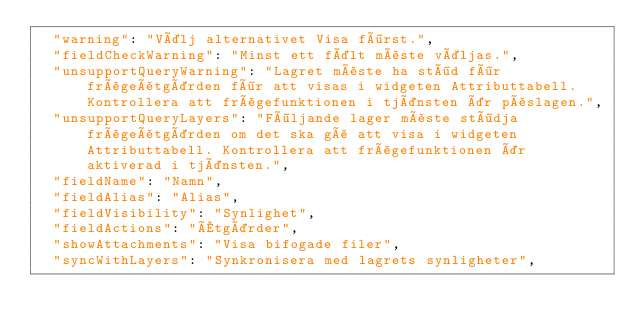Convert code to text. <code><loc_0><loc_0><loc_500><loc_500><_JavaScript_>  "warning": "Välj alternativet Visa först.",
  "fieldCheckWarning": "Minst ett fält måste väljas.",
  "unsupportQueryWarning": "Lagret måste ha stöd för frågeåtgärden för att visas i widgeten Attributtabell. Kontrollera att frågefunktionen i tjänsten är påslagen.",
  "unsupportQueryLayers": "Följande lager måste stödja frågeåtgärden om det ska gå att visa i widgeten Attributtabell. Kontrollera att frågefunktionen är aktiverad i tjänsten.",
  "fieldName": "Namn",
  "fieldAlias": "Alias",
  "fieldVisibility": "Synlighet",
  "fieldActions": "Åtgärder",
  "showAttachments": "Visa bifogade filer",
  "syncWithLayers": "Synkronisera med lagrets synligheter",</code> 